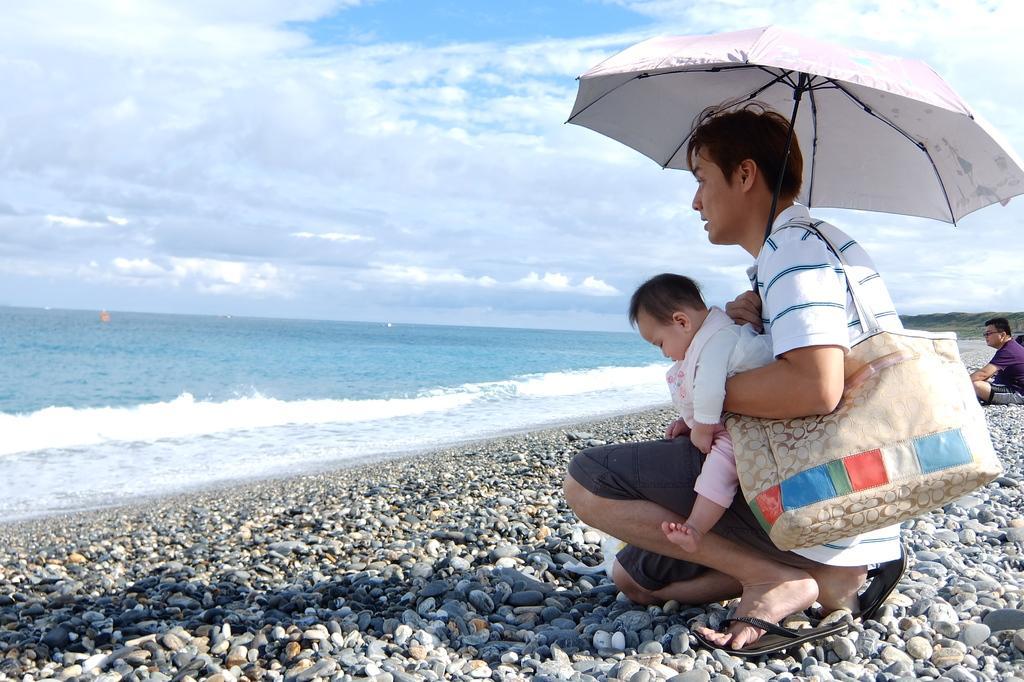How would you summarize this image in a sentence or two? In this image we can see a group of people. On the right side of the image we can see a person sitting on the ground. In the foreground we can see a person holding a baby with his hand and an umbrella in the other hand is carrying a bag. On the left side of the image we can see water. In the background, we can see the cloudy sky. 